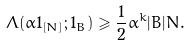<formula> <loc_0><loc_0><loc_500><loc_500>\Lambda ( \alpha 1 _ { [ N ] } ; 1 _ { B } ) \geqslant \frac { 1 } { 2 } \alpha ^ { k } | B | N .</formula> 